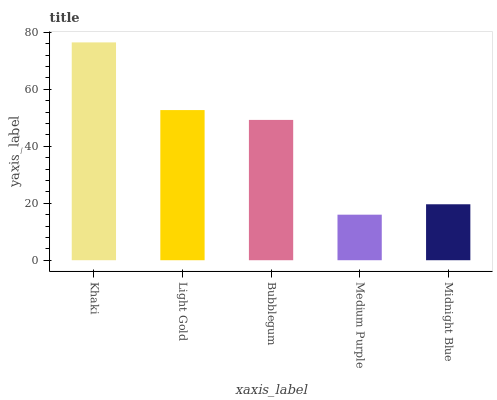Is Medium Purple the minimum?
Answer yes or no. Yes. Is Khaki the maximum?
Answer yes or no. Yes. Is Light Gold the minimum?
Answer yes or no. No. Is Light Gold the maximum?
Answer yes or no. No. Is Khaki greater than Light Gold?
Answer yes or no. Yes. Is Light Gold less than Khaki?
Answer yes or no. Yes. Is Light Gold greater than Khaki?
Answer yes or no. No. Is Khaki less than Light Gold?
Answer yes or no. No. Is Bubblegum the high median?
Answer yes or no. Yes. Is Bubblegum the low median?
Answer yes or no. Yes. Is Light Gold the high median?
Answer yes or no. No. Is Midnight Blue the low median?
Answer yes or no. No. 